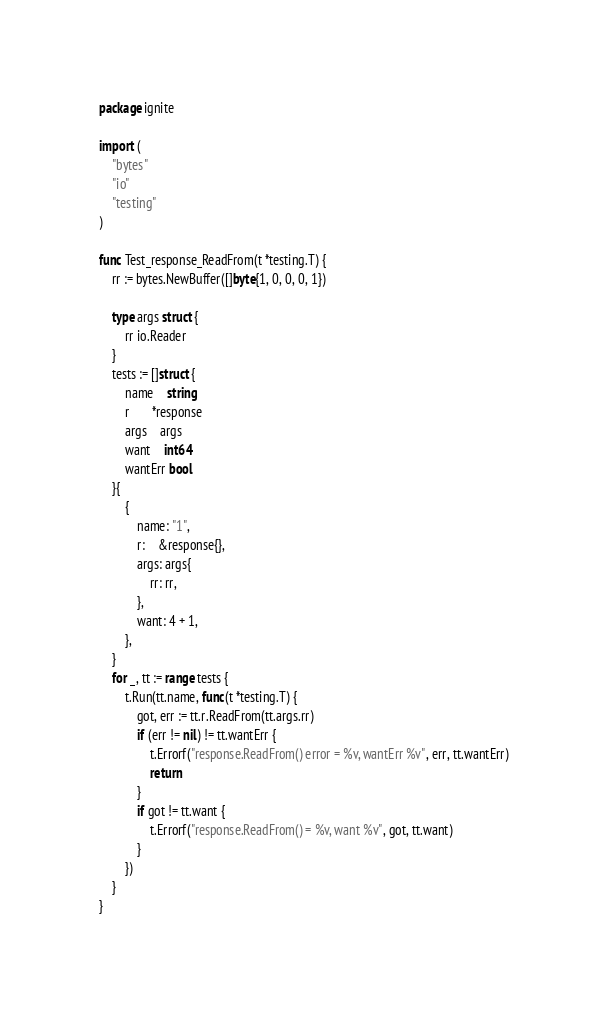<code> <loc_0><loc_0><loc_500><loc_500><_Go_>package ignite

import (
	"bytes"
	"io"
	"testing"
)

func Test_response_ReadFrom(t *testing.T) {
	rr := bytes.NewBuffer([]byte{1, 0, 0, 0, 1})

	type args struct {
		rr io.Reader
	}
	tests := []struct {
		name    string
		r       *response
		args    args
		want    int64
		wantErr bool
	}{
		{
			name: "1",
			r:    &response{},
			args: args{
				rr: rr,
			},
			want: 4 + 1,
		},
	}
	for _, tt := range tests {
		t.Run(tt.name, func(t *testing.T) {
			got, err := tt.r.ReadFrom(tt.args.rr)
			if (err != nil) != tt.wantErr {
				t.Errorf("response.ReadFrom() error = %v, wantErr %v", err, tt.wantErr)
				return
			}
			if got != tt.want {
				t.Errorf("response.ReadFrom() = %v, want %v", got, tt.want)
			}
		})
	}
}
</code> 